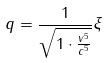Convert formula to latex. <formula><loc_0><loc_0><loc_500><loc_500>q = \frac { 1 } { \sqrt { 1 \cdot \frac { v ^ { 5 } } { c ^ { 5 } } } } \xi</formula> 